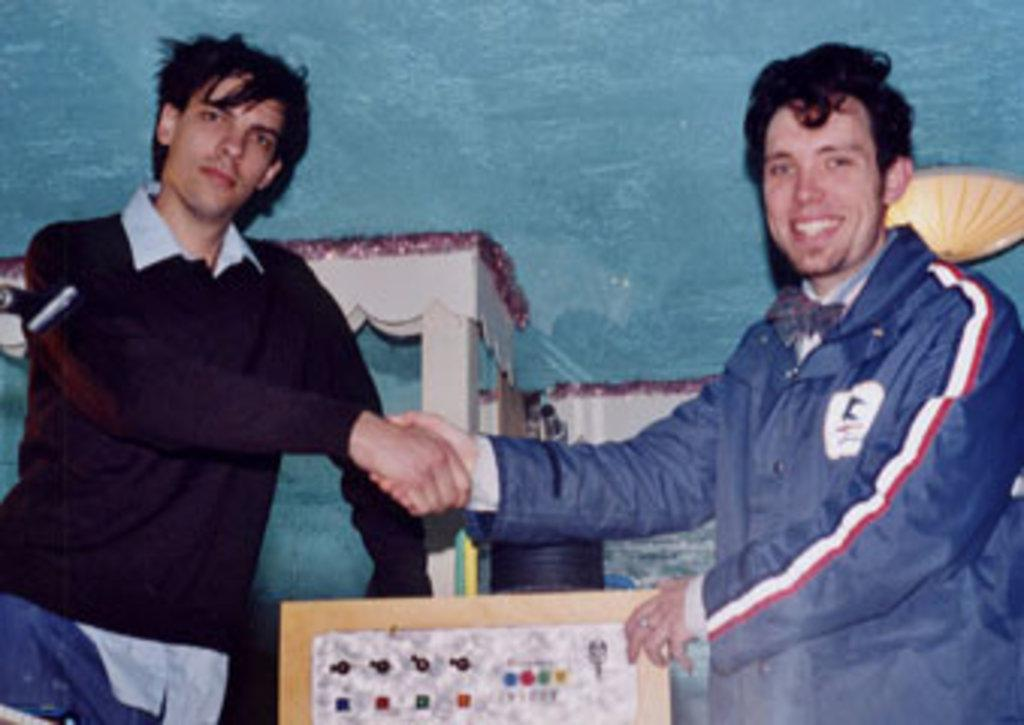What are the two persons in the image doing? The two persons in the image are standing and handshaking each other. What is the person on the left side of the image holding? The person on the left side of the image is holding a board. What can be seen in the background of the image? There is a table and other objects visible in the background. What type of beef is being served on the table in the image? There is no beef present in the image; the table and other objects in the background do not indicate any food items. 